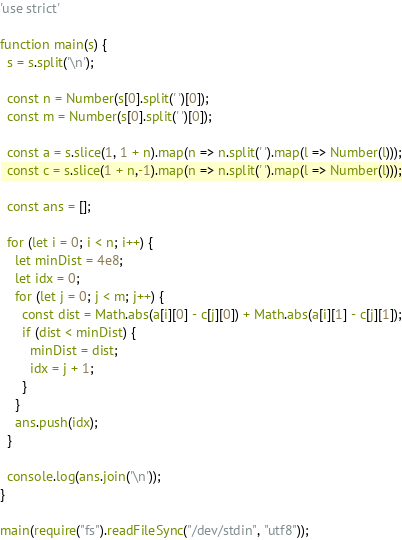Convert code to text. <code><loc_0><loc_0><loc_500><loc_500><_JavaScript_>'use strict'

function main(s) {
  s = s.split('\n');

  const n = Number(s[0].split(' ')[0]);
  const m = Number(s[0].split(' ')[0]);

  const a = s.slice(1, 1 + n).map(n => n.split(' ').map(l => Number(l)));
  const c = s.slice(1 + n,-1).map(n => n.split(' ').map(l => Number(l)));

  const ans = [];

  for (let i = 0; i < n; i++) {
    let minDist = 4e8;
    let idx = 0;
    for (let j = 0; j < m; j++) {
      const dist = Math.abs(a[i][0] - c[j][0]) + Math.abs(a[i][1] - c[j][1]);
      if (dist < minDist) {
        minDist = dist;
        idx = j + 1;
      }
    }
    ans.push(idx);
  }

  console.log(ans.join('\n'));
}

main(require("fs").readFileSync("/dev/stdin", "utf8"));
</code> 